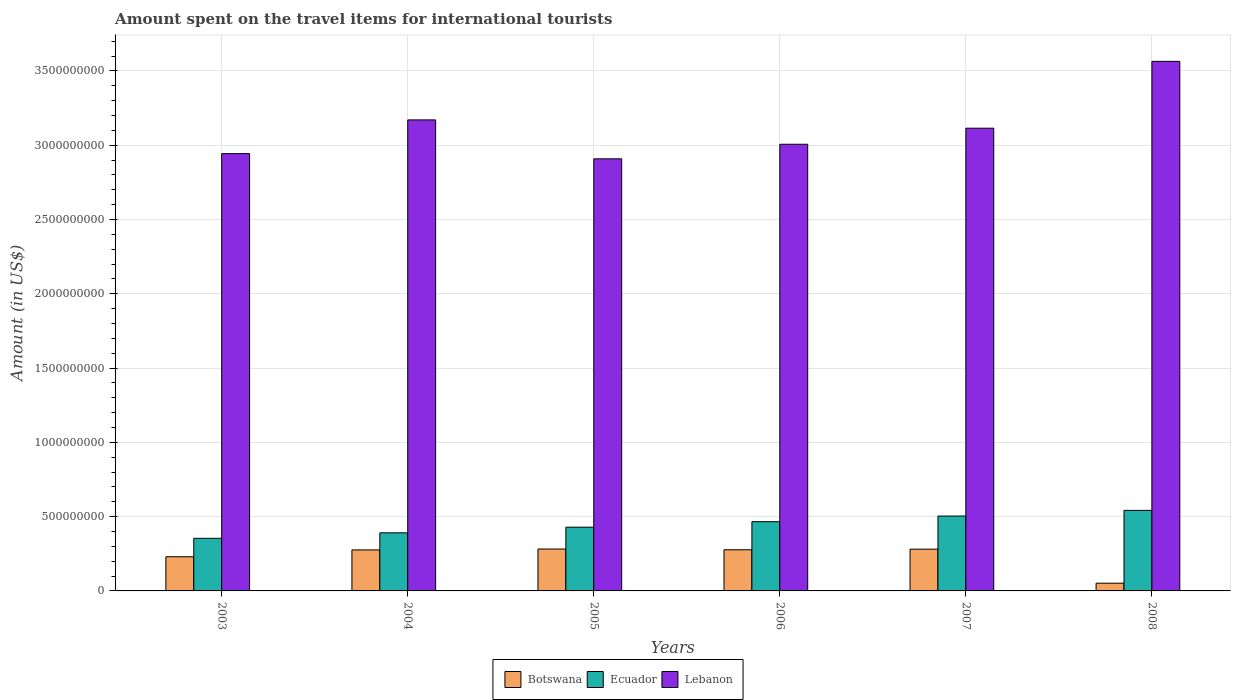How many different coloured bars are there?
Keep it short and to the point. 3. How many bars are there on the 5th tick from the left?
Your answer should be very brief. 3. In how many cases, is the number of bars for a given year not equal to the number of legend labels?
Keep it short and to the point. 0. What is the amount spent on the travel items for international tourists in Ecuador in 2004?
Offer a very short reply. 3.91e+08. Across all years, what is the maximum amount spent on the travel items for international tourists in Lebanon?
Provide a succinct answer. 3.56e+09. Across all years, what is the minimum amount spent on the travel items for international tourists in Lebanon?
Your response must be concise. 2.91e+09. In which year was the amount spent on the travel items for international tourists in Ecuador maximum?
Provide a succinct answer. 2008. In which year was the amount spent on the travel items for international tourists in Botswana minimum?
Provide a succinct answer. 2008. What is the total amount spent on the travel items for international tourists in Ecuador in the graph?
Provide a short and direct response. 2.69e+09. What is the difference between the amount spent on the travel items for international tourists in Lebanon in 2006 and that in 2007?
Your answer should be compact. -1.08e+08. What is the difference between the amount spent on the travel items for international tourists in Ecuador in 2007 and the amount spent on the travel items for international tourists in Botswana in 2004?
Make the answer very short. 2.28e+08. What is the average amount spent on the travel items for international tourists in Lebanon per year?
Offer a terse response. 3.12e+09. In the year 2004, what is the difference between the amount spent on the travel items for international tourists in Botswana and amount spent on the travel items for international tourists in Lebanon?
Your answer should be compact. -2.89e+09. In how many years, is the amount spent on the travel items for international tourists in Botswana greater than 800000000 US$?
Your answer should be compact. 0. What is the ratio of the amount spent on the travel items for international tourists in Botswana in 2004 to that in 2006?
Make the answer very short. 1. What is the difference between the highest and the second highest amount spent on the travel items for international tourists in Ecuador?
Give a very brief answer. 3.80e+07. What is the difference between the highest and the lowest amount spent on the travel items for international tourists in Botswana?
Offer a very short reply. 2.30e+08. In how many years, is the amount spent on the travel items for international tourists in Ecuador greater than the average amount spent on the travel items for international tourists in Ecuador taken over all years?
Your answer should be compact. 3. What does the 2nd bar from the left in 2008 represents?
Provide a short and direct response. Ecuador. What does the 1st bar from the right in 2004 represents?
Provide a short and direct response. Lebanon. How many bars are there?
Your answer should be very brief. 18. Are all the bars in the graph horizontal?
Provide a short and direct response. No. How many years are there in the graph?
Offer a terse response. 6. What is the difference between two consecutive major ticks on the Y-axis?
Give a very brief answer. 5.00e+08. Are the values on the major ticks of Y-axis written in scientific E-notation?
Make the answer very short. No. Does the graph contain any zero values?
Provide a short and direct response. No. Does the graph contain grids?
Keep it short and to the point. Yes. Where does the legend appear in the graph?
Offer a very short reply. Bottom center. What is the title of the graph?
Give a very brief answer. Amount spent on the travel items for international tourists. What is the label or title of the X-axis?
Your response must be concise. Years. What is the label or title of the Y-axis?
Your answer should be very brief. Amount (in US$). What is the Amount (in US$) in Botswana in 2003?
Offer a very short reply. 2.30e+08. What is the Amount (in US$) in Ecuador in 2003?
Your response must be concise. 3.54e+08. What is the Amount (in US$) of Lebanon in 2003?
Make the answer very short. 2.94e+09. What is the Amount (in US$) of Botswana in 2004?
Provide a succinct answer. 2.76e+08. What is the Amount (in US$) of Ecuador in 2004?
Your answer should be very brief. 3.91e+08. What is the Amount (in US$) in Lebanon in 2004?
Provide a succinct answer. 3.17e+09. What is the Amount (in US$) of Botswana in 2005?
Your response must be concise. 2.82e+08. What is the Amount (in US$) of Ecuador in 2005?
Your response must be concise. 4.29e+08. What is the Amount (in US$) of Lebanon in 2005?
Provide a succinct answer. 2.91e+09. What is the Amount (in US$) of Botswana in 2006?
Your response must be concise. 2.77e+08. What is the Amount (in US$) of Ecuador in 2006?
Make the answer very short. 4.66e+08. What is the Amount (in US$) of Lebanon in 2006?
Ensure brevity in your answer.  3.01e+09. What is the Amount (in US$) of Botswana in 2007?
Ensure brevity in your answer.  2.81e+08. What is the Amount (in US$) in Ecuador in 2007?
Your answer should be very brief. 5.04e+08. What is the Amount (in US$) of Lebanon in 2007?
Your answer should be compact. 3.11e+09. What is the Amount (in US$) in Botswana in 2008?
Provide a succinct answer. 5.20e+07. What is the Amount (in US$) of Ecuador in 2008?
Give a very brief answer. 5.42e+08. What is the Amount (in US$) of Lebanon in 2008?
Keep it short and to the point. 3.56e+09. Across all years, what is the maximum Amount (in US$) of Botswana?
Provide a short and direct response. 2.82e+08. Across all years, what is the maximum Amount (in US$) of Ecuador?
Make the answer very short. 5.42e+08. Across all years, what is the maximum Amount (in US$) of Lebanon?
Ensure brevity in your answer.  3.56e+09. Across all years, what is the minimum Amount (in US$) in Botswana?
Provide a succinct answer. 5.20e+07. Across all years, what is the minimum Amount (in US$) of Ecuador?
Offer a terse response. 3.54e+08. Across all years, what is the minimum Amount (in US$) of Lebanon?
Ensure brevity in your answer.  2.91e+09. What is the total Amount (in US$) of Botswana in the graph?
Offer a very short reply. 1.40e+09. What is the total Amount (in US$) of Ecuador in the graph?
Your answer should be compact. 2.69e+09. What is the total Amount (in US$) of Lebanon in the graph?
Make the answer very short. 1.87e+1. What is the difference between the Amount (in US$) in Botswana in 2003 and that in 2004?
Give a very brief answer. -4.60e+07. What is the difference between the Amount (in US$) in Ecuador in 2003 and that in 2004?
Keep it short and to the point. -3.70e+07. What is the difference between the Amount (in US$) of Lebanon in 2003 and that in 2004?
Offer a very short reply. -2.27e+08. What is the difference between the Amount (in US$) in Botswana in 2003 and that in 2005?
Keep it short and to the point. -5.20e+07. What is the difference between the Amount (in US$) of Ecuador in 2003 and that in 2005?
Give a very brief answer. -7.50e+07. What is the difference between the Amount (in US$) of Lebanon in 2003 and that in 2005?
Your response must be concise. 3.50e+07. What is the difference between the Amount (in US$) in Botswana in 2003 and that in 2006?
Keep it short and to the point. -4.70e+07. What is the difference between the Amount (in US$) in Ecuador in 2003 and that in 2006?
Your response must be concise. -1.12e+08. What is the difference between the Amount (in US$) in Lebanon in 2003 and that in 2006?
Provide a short and direct response. -6.30e+07. What is the difference between the Amount (in US$) of Botswana in 2003 and that in 2007?
Keep it short and to the point. -5.10e+07. What is the difference between the Amount (in US$) in Ecuador in 2003 and that in 2007?
Make the answer very short. -1.50e+08. What is the difference between the Amount (in US$) in Lebanon in 2003 and that in 2007?
Offer a terse response. -1.71e+08. What is the difference between the Amount (in US$) in Botswana in 2003 and that in 2008?
Offer a very short reply. 1.78e+08. What is the difference between the Amount (in US$) in Ecuador in 2003 and that in 2008?
Make the answer very short. -1.88e+08. What is the difference between the Amount (in US$) of Lebanon in 2003 and that in 2008?
Offer a very short reply. -6.21e+08. What is the difference between the Amount (in US$) of Botswana in 2004 and that in 2005?
Offer a very short reply. -6.00e+06. What is the difference between the Amount (in US$) of Ecuador in 2004 and that in 2005?
Offer a terse response. -3.80e+07. What is the difference between the Amount (in US$) of Lebanon in 2004 and that in 2005?
Your answer should be very brief. 2.62e+08. What is the difference between the Amount (in US$) of Botswana in 2004 and that in 2006?
Offer a terse response. -1.00e+06. What is the difference between the Amount (in US$) of Ecuador in 2004 and that in 2006?
Give a very brief answer. -7.50e+07. What is the difference between the Amount (in US$) in Lebanon in 2004 and that in 2006?
Provide a succinct answer. 1.64e+08. What is the difference between the Amount (in US$) in Botswana in 2004 and that in 2007?
Your response must be concise. -5.00e+06. What is the difference between the Amount (in US$) in Ecuador in 2004 and that in 2007?
Offer a very short reply. -1.13e+08. What is the difference between the Amount (in US$) in Lebanon in 2004 and that in 2007?
Your answer should be very brief. 5.60e+07. What is the difference between the Amount (in US$) in Botswana in 2004 and that in 2008?
Make the answer very short. 2.24e+08. What is the difference between the Amount (in US$) in Ecuador in 2004 and that in 2008?
Your response must be concise. -1.51e+08. What is the difference between the Amount (in US$) of Lebanon in 2004 and that in 2008?
Give a very brief answer. -3.94e+08. What is the difference between the Amount (in US$) in Ecuador in 2005 and that in 2006?
Your answer should be very brief. -3.70e+07. What is the difference between the Amount (in US$) of Lebanon in 2005 and that in 2006?
Make the answer very short. -9.80e+07. What is the difference between the Amount (in US$) of Ecuador in 2005 and that in 2007?
Provide a succinct answer. -7.50e+07. What is the difference between the Amount (in US$) of Lebanon in 2005 and that in 2007?
Make the answer very short. -2.06e+08. What is the difference between the Amount (in US$) of Botswana in 2005 and that in 2008?
Ensure brevity in your answer.  2.30e+08. What is the difference between the Amount (in US$) in Ecuador in 2005 and that in 2008?
Offer a terse response. -1.13e+08. What is the difference between the Amount (in US$) in Lebanon in 2005 and that in 2008?
Provide a short and direct response. -6.56e+08. What is the difference between the Amount (in US$) of Botswana in 2006 and that in 2007?
Provide a succinct answer. -4.00e+06. What is the difference between the Amount (in US$) of Ecuador in 2006 and that in 2007?
Provide a succinct answer. -3.80e+07. What is the difference between the Amount (in US$) of Lebanon in 2006 and that in 2007?
Your response must be concise. -1.08e+08. What is the difference between the Amount (in US$) of Botswana in 2006 and that in 2008?
Your answer should be very brief. 2.25e+08. What is the difference between the Amount (in US$) in Ecuador in 2006 and that in 2008?
Give a very brief answer. -7.60e+07. What is the difference between the Amount (in US$) of Lebanon in 2006 and that in 2008?
Keep it short and to the point. -5.58e+08. What is the difference between the Amount (in US$) in Botswana in 2007 and that in 2008?
Provide a succinct answer. 2.29e+08. What is the difference between the Amount (in US$) in Ecuador in 2007 and that in 2008?
Offer a terse response. -3.80e+07. What is the difference between the Amount (in US$) of Lebanon in 2007 and that in 2008?
Provide a short and direct response. -4.50e+08. What is the difference between the Amount (in US$) in Botswana in 2003 and the Amount (in US$) in Ecuador in 2004?
Give a very brief answer. -1.61e+08. What is the difference between the Amount (in US$) in Botswana in 2003 and the Amount (in US$) in Lebanon in 2004?
Offer a very short reply. -2.94e+09. What is the difference between the Amount (in US$) in Ecuador in 2003 and the Amount (in US$) in Lebanon in 2004?
Ensure brevity in your answer.  -2.82e+09. What is the difference between the Amount (in US$) of Botswana in 2003 and the Amount (in US$) of Ecuador in 2005?
Provide a short and direct response. -1.99e+08. What is the difference between the Amount (in US$) of Botswana in 2003 and the Amount (in US$) of Lebanon in 2005?
Offer a terse response. -2.68e+09. What is the difference between the Amount (in US$) of Ecuador in 2003 and the Amount (in US$) of Lebanon in 2005?
Ensure brevity in your answer.  -2.55e+09. What is the difference between the Amount (in US$) in Botswana in 2003 and the Amount (in US$) in Ecuador in 2006?
Your answer should be compact. -2.36e+08. What is the difference between the Amount (in US$) in Botswana in 2003 and the Amount (in US$) in Lebanon in 2006?
Keep it short and to the point. -2.78e+09. What is the difference between the Amount (in US$) of Ecuador in 2003 and the Amount (in US$) of Lebanon in 2006?
Provide a short and direct response. -2.65e+09. What is the difference between the Amount (in US$) of Botswana in 2003 and the Amount (in US$) of Ecuador in 2007?
Provide a short and direct response. -2.74e+08. What is the difference between the Amount (in US$) in Botswana in 2003 and the Amount (in US$) in Lebanon in 2007?
Your answer should be compact. -2.88e+09. What is the difference between the Amount (in US$) in Ecuador in 2003 and the Amount (in US$) in Lebanon in 2007?
Your response must be concise. -2.76e+09. What is the difference between the Amount (in US$) of Botswana in 2003 and the Amount (in US$) of Ecuador in 2008?
Offer a terse response. -3.12e+08. What is the difference between the Amount (in US$) in Botswana in 2003 and the Amount (in US$) in Lebanon in 2008?
Offer a very short reply. -3.33e+09. What is the difference between the Amount (in US$) in Ecuador in 2003 and the Amount (in US$) in Lebanon in 2008?
Give a very brief answer. -3.21e+09. What is the difference between the Amount (in US$) in Botswana in 2004 and the Amount (in US$) in Ecuador in 2005?
Ensure brevity in your answer.  -1.53e+08. What is the difference between the Amount (in US$) in Botswana in 2004 and the Amount (in US$) in Lebanon in 2005?
Provide a short and direct response. -2.63e+09. What is the difference between the Amount (in US$) of Ecuador in 2004 and the Amount (in US$) of Lebanon in 2005?
Your answer should be compact. -2.52e+09. What is the difference between the Amount (in US$) of Botswana in 2004 and the Amount (in US$) of Ecuador in 2006?
Your response must be concise. -1.90e+08. What is the difference between the Amount (in US$) in Botswana in 2004 and the Amount (in US$) in Lebanon in 2006?
Provide a short and direct response. -2.73e+09. What is the difference between the Amount (in US$) of Ecuador in 2004 and the Amount (in US$) of Lebanon in 2006?
Your answer should be compact. -2.62e+09. What is the difference between the Amount (in US$) in Botswana in 2004 and the Amount (in US$) in Ecuador in 2007?
Keep it short and to the point. -2.28e+08. What is the difference between the Amount (in US$) of Botswana in 2004 and the Amount (in US$) of Lebanon in 2007?
Your answer should be compact. -2.84e+09. What is the difference between the Amount (in US$) of Ecuador in 2004 and the Amount (in US$) of Lebanon in 2007?
Provide a succinct answer. -2.72e+09. What is the difference between the Amount (in US$) of Botswana in 2004 and the Amount (in US$) of Ecuador in 2008?
Your answer should be very brief. -2.66e+08. What is the difference between the Amount (in US$) of Botswana in 2004 and the Amount (in US$) of Lebanon in 2008?
Ensure brevity in your answer.  -3.29e+09. What is the difference between the Amount (in US$) of Ecuador in 2004 and the Amount (in US$) of Lebanon in 2008?
Offer a terse response. -3.17e+09. What is the difference between the Amount (in US$) in Botswana in 2005 and the Amount (in US$) in Ecuador in 2006?
Provide a short and direct response. -1.84e+08. What is the difference between the Amount (in US$) in Botswana in 2005 and the Amount (in US$) in Lebanon in 2006?
Your answer should be very brief. -2.72e+09. What is the difference between the Amount (in US$) in Ecuador in 2005 and the Amount (in US$) in Lebanon in 2006?
Make the answer very short. -2.58e+09. What is the difference between the Amount (in US$) of Botswana in 2005 and the Amount (in US$) of Ecuador in 2007?
Provide a succinct answer. -2.22e+08. What is the difference between the Amount (in US$) of Botswana in 2005 and the Amount (in US$) of Lebanon in 2007?
Your response must be concise. -2.83e+09. What is the difference between the Amount (in US$) of Ecuador in 2005 and the Amount (in US$) of Lebanon in 2007?
Offer a very short reply. -2.68e+09. What is the difference between the Amount (in US$) in Botswana in 2005 and the Amount (in US$) in Ecuador in 2008?
Keep it short and to the point. -2.60e+08. What is the difference between the Amount (in US$) of Botswana in 2005 and the Amount (in US$) of Lebanon in 2008?
Provide a short and direct response. -3.28e+09. What is the difference between the Amount (in US$) in Ecuador in 2005 and the Amount (in US$) in Lebanon in 2008?
Keep it short and to the point. -3.14e+09. What is the difference between the Amount (in US$) in Botswana in 2006 and the Amount (in US$) in Ecuador in 2007?
Your response must be concise. -2.27e+08. What is the difference between the Amount (in US$) in Botswana in 2006 and the Amount (in US$) in Lebanon in 2007?
Keep it short and to the point. -2.84e+09. What is the difference between the Amount (in US$) in Ecuador in 2006 and the Amount (in US$) in Lebanon in 2007?
Your answer should be very brief. -2.65e+09. What is the difference between the Amount (in US$) of Botswana in 2006 and the Amount (in US$) of Ecuador in 2008?
Ensure brevity in your answer.  -2.65e+08. What is the difference between the Amount (in US$) of Botswana in 2006 and the Amount (in US$) of Lebanon in 2008?
Your response must be concise. -3.29e+09. What is the difference between the Amount (in US$) of Ecuador in 2006 and the Amount (in US$) of Lebanon in 2008?
Keep it short and to the point. -3.10e+09. What is the difference between the Amount (in US$) in Botswana in 2007 and the Amount (in US$) in Ecuador in 2008?
Keep it short and to the point. -2.61e+08. What is the difference between the Amount (in US$) of Botswana in 2007 and the Amount (in US$) of Lebanon in 2008?
Offer a very short reply. -3.28e+09. What is the difference between the Amount (in US$) of Ecuador in 2007 and the Amount (in US$) of Lebanon in 2008?
Keep it short and to the point. -3.06e+09. What is the average Amount (in US$) of Botswana per year?
Give a very brief answer. 2.33e+08. What is the average Amount (in US$) of Ecuador per year?
Give a very brief answer. 4.48e+08. What is the average Amount (in US$) of Lebanon per year?
Ensure brevity in your answer.  3.12e+09. In the year 2003, what is the difference between the Amount (in US$) of Botswana and Amount (in US$) of Ecuador?
Provide a short and direct response. -1.24e+08. In the year 2003, what is the difference between the Amount (in US$) in Botswana and Amount (in US$) in Lebanon?
Your answer should be compact. -2.71e+09. In the year 2003, what is the difference between the Amount (in US$) in Ecuador and Amount (in US$) in Lebanon?
Ensure brevity in your answer.  -2.59e+09. In the year 2004, what is the difference between the Amount (in US$) of Botswana and Amount (in US$) of Ecuador?
Give a very brief answer. -1.15e+08. In the year 2004, what is the difference between the Amount (in US$) in Botswana and Amount (in US$) in Lebanon?
Provide a short and direct response. -2.89e+09. In the year 2004, what is the difference between the Amount (in US$) in Ecuador and Amount (in US$) in Lebanon?
Ensure brevity in your answer.  -2.78e+09. In the year 2005, what is the difference between the Amount (in US$) of Botswana and Amount (in US$) of Ecuador?
Ensure brevity in your answer.  -1.47e+08. In the year 2005, what is the difference between the Amount (in US$) in Botswana and Amount (in US$) in Lebanon?
Offer a very short reply. -2.63e+09. In the year 2005, what is the difference between the Amount (in US$) of Ecuador and Amount (in US$) of Lebanon?
Your answer should be very brief. -2.48e+09. In the year 2006, what is the difference between the Amount (in US$) in Botswana and Amount (in US$) in Ecuador?
Make the answer very short. -1.89e+08. In the year 2006, what is the difference between the Amount (in US$) of Botswana and Amount (in US$) of Lebanon?
Ensure brevity in your answer.  -2.73e+09. In the year 2006, what is the difference between the Amount (in US$) of Ecuador and Amount (in US$) of Lebanon?
Keep it short and to the point. -2.54e+09. In the year 2007, what is the difference between the Amount (in US$) in Botswana and Amount (in US$) in Ecuador?
Offer a terse response. -2.23e+08. In the year 2007, what is the difference between the Amount (in US$) of Botswana and Amount (in US$) of Lebanon?
Your response must be concise. -2.83e+09. In the year 2007, what is the difference between the Amount (in US$) in Ecuador and Amount (in US$) in Lebanon?
Your answer should be very brief. -2.61e+09. In the year 2008, what is the difference between the Amount (in US$) of Botswana and Amount (in US$) of Ecuador?
Ensure brevity in your answer.  -4.90e+08. In the year 2008, what is the difference between the Amount (in US$) of Botswana and Amount (in US$) of Lebanon?
Ensure brevity in your answer.  -3.51e+09. In the year 2008, what is the difference between the Amount (in US$) of Ecuador and Amount (in US$) of Lebanon?
Your response must be concise. -3.02e+09. What is the ratio of the Amount (in US$) in Botswana in 2003 to that in 2004?
Provide a succinct answer. 0.83. What is the ratio of the Amount (in US$) of Ecuador in 2003 to that in 2004?
Make the answer very short. 0.91. What is the ratio of the Amount (in US$) in Lebanon in 2003 to that in 2004?
Offer a terse response. 0.93. What is the ratio of the Amount (in US$) of Botswana in 2003 to that in 2005?
Give a very brief answer. 0.82. What is the ratio of the Amount (in US$) of Ecuador in 2003 to that in 2005?
Your response must be concise. 0.83. What is the ratio of the Amount (in US$) of Botswana in 2003 to that in 2006?
Your answer should be very brief. 0.83. What is the ratio of the Amount (in US$) of Ecuador in 2003 to that in 2006?
Make the answer very short. 0.76. What is the ratio of the Amount (in US$) of Lebanon in 2003 to that in 2006?
Your answer should be very brief. 0.98. What is the ratio of the Amount (in US$) in Botswana in 2003 to that in 2007?
Give a very brief answer. 0.82. What is the ratio of the Amount (in US$) in Ecuador in 2003 to that in 2007?
Offer a terse response. 0.7. What is the ratio of the Amount (in US$) of Lebanon in 2003 to that in 2007?
Offer a very short reply. 0.95. What is the ratio of the Amount (in US$) in Botswana in 2003 to that in 2008?
Your answer should be very brief. 4.42. What is the ratio of the Amount (in US$) of Ecuador in 2003 to that in 2008?
Your answer should be compact. 0.65. What is the ratio of the Amount (in US$) of Lebanon in 2003 to that in 2008?
Provide a short and direct response. 0.83. What is the ratio of the Amount (in US$) of Botswana in 2004 to that in 2005?
Your answer should be compact. 0.98. What is the ratio of the Amount (in US$) in Ecuador in 2004 to that in 2005?
Provide a short and direct response. 0.91. What is the ratio of the Amount (in US$) in Lebanon in 2004 to that in 2005?
Make the answer very short. 1.09. What is the ratio of the Amount (in US$) in Ecuador in 2004 to that in 2006?
Provide a succinct answer. 0.84. What is the ratio of the Amount (in US$) of Lebanon in 2004 to that in 2006?
Give a very brief answer. 1.05. What is the ratio of the Amount (in US$) in Botswana in 2004 to that in 2007?
Offer a very short reply. 0.98. What is the ratio of the Amount (in US$) in Ecuador in 2004 to that in 2007?
Ensure brevity in your answer.  0.78. What is the ratio of the Amount (in US$) in Lebanon in 2004 to that in 2007?
Provide a succinct answer. 1.02. What is the ratio of the Amount (in US$) in Botswana in 2004 to that in 2008?
Keep it short and to the point. 5.31. What is the ratio of the Amount (in US$) in Ecuador in 2004 to that in 2008?
Give a very brief answer. 0.72. What is the ratio of the Amount (in US$) in Lebanon in 2004 to that in 2008?
Provide a succinct answer. 0.89. What is the ratio of the Amount (in US$) of Botswana in 2005 to that in 2006?
Provide a short and direct response. 1.02. What is the ratio of the Amount (in US$) of Ecuador in 2005 to that in 2006?
Ensure brevity in your answer.  0.92. What is the ratio of the Amount (in US$) in Lebanon in 2005 to that in 2006?
Ensure brevity in your answer.  0.97. What is the ratio of the Amount (in US$) in Botswana in 2005 to that in 2007?
Make the answer very short. 1. What is the ratio of the Amount (in US$) in Ecuador in 2005 to that in 2007?
Your answer should be compact. 0.85. What is the ratio of the Amount (in US$) of Lebanon in 2005 to that in 2007?
Make the answer very short. 0.93. What is the ratio of the Amount (in US$) in Botswana in 2005 to that in 2008?
Offer a terse response. 5.42. What is the ratio of the Amount (in US$) of Ecuador in 2005 to that in 2008?
Provide a short and direct response. 0.79. What is the ratio of the Amount (in US$) of Lebanon in 2005 to that in 2008?
Your answer should be very brief. 0.82. What is the ratio of the Amount (in US$) of Botswana in 2006 to that in 2007?
Your response must be concise. 0.99. What is the ratio of the Amount (in US$) in Ecuador in 2006 to that in 2007?
Give a very brief answer. 0.92. What is the ratio of the Amount (in US$) in Lebanon in 2006 to that in 2007?
Make the answer very short. 0.97. What is the ratio of the Amount (in US$) in Botswana in 2006 to that in 2008?
Give a very brief answer. 5.33. What is the ratio of the Amount (in US$) in Ecuador in 2006 to that in 2008?
Your response must be concise. 0.86. What is the ratio of the Amount (in US$) of Lebanon in 2006 to that in 2008?
Your answer should be very brief. 0.84. What is the ratio of the Amount (in US$) of Botswana in 2007 to that in 2008?
Keep it short and to the point. 5.4. What is the ratio of the Amount (in US$) of Ecuador in 2007 to that in 2008?
Make the answer very short. 0.93. What is the ratio of the Amount (in US$) of Lebanon in 2007 to that in 2008?
Your answer should be compact. 0.87. What is the difference between the highest and the second highest Amount (in US$) in Botswana?
Your answer should be very brief. 1.00e+06. What is the difference between the highest and the second highest Amount (in US$) of Ecuador?
Offer a very short reply. 3.80e+07. What is the difference between the highest and the second highest Amount (in US$) of Lebanon?
Provide a succinct answer. 3.94e+08. What is the difference between the highest and the lowest Amount (in US$) of Botswana?
Ensure brevity in your answer.  2.30e+08. What is the difference between the highest and the lowest Amount (in US$) of Ecuador?
Provide a short and direct response. 1.88e+08. What is the difference between the highest and the lowest Amount (in US$) in Lebanon?
Ensure brevity in your answer.  6.56e+08. 